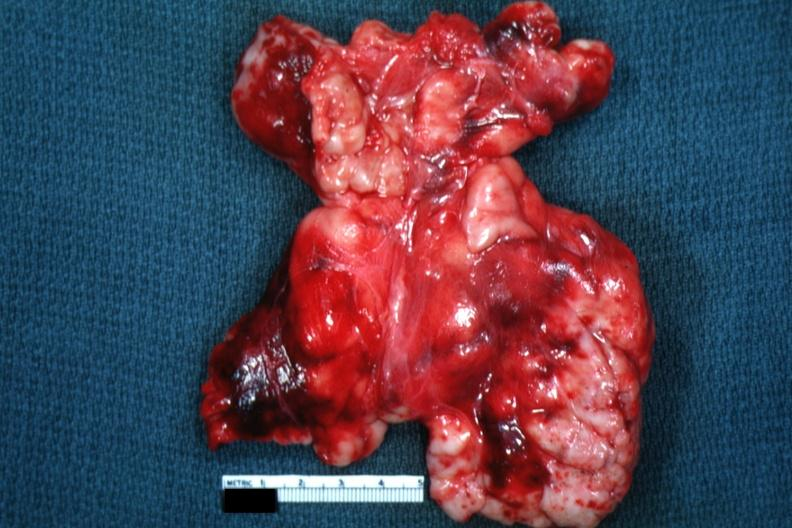what is present?
Answer the question using a single word or phrase. Hematologic 